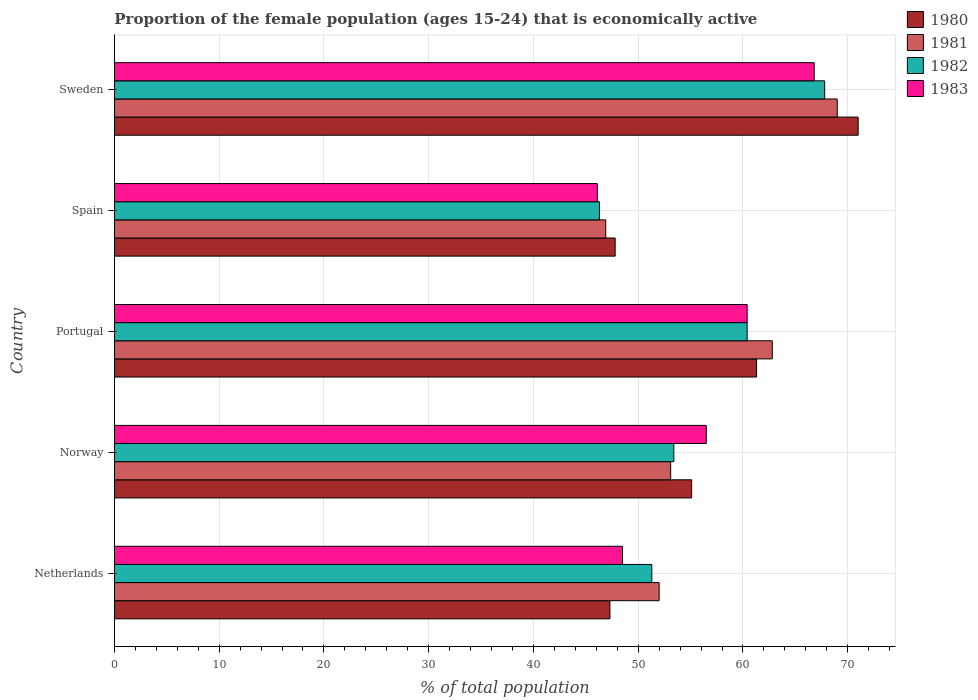How many groups of bars are there?
Offer a very short reply. 5. Are the number of bars on each tick of the Y-axis equal?
Provide a succinct answer. Yes. How many bars are there on the 1st tick from the bottom?
Give a very brief answer. 4. What is the label of the 1st group of bars from the top?
Your answer should be compact. Sweden. In how many cases, is the number of bars for a given country not equal to the number of legend labels?
Offer a terse response. 0. What is the proportion of the female population that is economically active in 1982 in Spain?
Offer a terse response. 46.3. Across all countries, what is the maximum proportion of the female population that is economically active in 1980?
Your response must be concise. 71. Across all countries, what is the minimum proportion of the female population that is economically active in 1983?
Ensure brevity in your answer.  46.1. What is the total proportion of the female population that is economically active in 1983 in the graph?
Offer a terse response. 278.3. What is the difference between the proportion of the female population that is economically active in 1982 in Spain and that in Sweden?
Ensure brevity in your answer.  -21.5. What is the difference between the proportion of the female population that is economically active in 1983 in Portugal and the proportion of the female population that is economically active in 1981 in Netherlands?
Keep it short and to the point. 8.4. What is the average proportion of the female population that is economically active in 1983 per country?
Your response must be concise. 55.66. What is the difference between the proportion of the female population that is economically active in 1981 and proportion of the female population that is economically active in 1982 in Sweden?
Offer a very short reply. 1.2. In how many countries, is the proportion of the female population that is economically active in 1980 greater than 44 %?
Your answer should be compact. 5. What is the ratio of the proportion of the female population that is economically active in 1983 in Norway to that in Spain?
Give a very brief answer. 1.23. Is the proportion of the female population that is economically active in 1981 in Netherlands less than that in Portugal?
Provide a succinct answer. Yes. What is the difference between the highest and the second highest proportion of the female population that is economically active in 1981?
Make the answer very short. 6.2. What is the difference between the highest and the lowest proportion of the female population that is economically active in 1980?
Make the answer very short. 23.7. Is the sum of the proportion of the female population that is economically active in 1981 in Netherlands and Sweden greater than the maximum proportion of the female population that is economically active in 1982 across all countries?
Provide a succinct answer. Yes. What does the 1st bar from the bottom in Spain represents?
Give a very brief answer. 1980. Does the graph contain any zero values?
Ensure brevity in your answer.  No. Where does the legend appear in the graph?
Your answer should be compact. Top right. What is the title of the graph?
Your response must be concise. Proportion of the female population (ages 15-24) that is economically active. Does "1997" appear as one of the legend labels in the graph?
Offer a very short reply. No. What is the label or title of the X-axis?
Your answer should be very brief. % of total population. What is the % of total population of 1980 in Netherlands?
Offer a terse response. 47.3. What is the % of total population in 1982 in Netherlands?
Your answer should be very brief. 51.3. What is the % of total population in 1983 in Netherlands?
Make the answer very short. 48.5. What is the % of total population of 1980 in Norway?
Your answer should be very brief. 55.1. What is the % of total population in 1981 in Norway?
Your answer should be compact. 53.1. What is the % of total population in 1982 in Norway?
Your response must be concise. 53.4. What is the % of total population of 1983 in Norway?
Offer a terse response. 56.5. What is the % of total population of 1980 in Portugal?
Make the answer very short. 61.3. What is the % of total population of 1981 in Portugal?
Your response must be concise. 62.8. What is the % of total population of 1982 in Portugal?
Offer a terse response. 60.4. What is the % of total population in 1983 in Portugal?
Your answer should be compact. 60.4. What is the % of total population in 1980 in Spain?
Provide a succinct answer. 47.8. What is the % of total population of 1981 in Spain?
Ensure brevity in your answer.  46.9. What is the % of total population of 1982 in Spain?
Keep it short and to the point. 46.3. What is the % of total population of 1983 in Spain?
Your response must be concise. 46.1. What is the % of total population of 1980 in Sweden?
Offer a very short reply. 71. What is the % of total population of 1981 in Sweden?
Offer a terse response. 69. What is the % of total population in 1982 in Sweden?
Offer a very short reply. 67.8. What is the % of total population in 1983 in Sweden?
Your response must be concise. 66.8. Across all countries, what is the maximum % of total population in 1980?
Offer a terse response. 71. Across all countries, what is the maximum % of total population in 1981?
Offer a terse response. 69. Across all countries, what is the maximum % of total population of 1982?
Provide a short and direct response. 67.8. Across all countries, what is the maximum % of total population in 1983?
Give a very brief answer. 66.8. Across all countries, what is the minimum % of total population of 1980?
Ensure brevity in your answer.  47.3. Across all countries, what is the minimum % of total population of 1981?
Provide a short and direct response. 46.9. Across all countries, what is the minimum % of total population in 1982?
Provide a short and direct response. 46.3. Across all countries, what is the minimum % of total population of 1983?
Keep it short and to the point. 46.1. What is the total % of total population in 1980 in the graph?
Make the answer very short. 282.5. What is the total % of total population of 1981 in the graph?
Your response must be concise. 283.8. What is the total % of total population of 1982 in the graph?
Your answer should be compact. 279.2. What is the total % of total population of 1983 in the graph?
Provide a succinct answer. 278.3. What is the difference between the % of total population in 1981 in Netherlands and that in Norway?
Your response must be concise. -1.1. What is the difference between the % of total population of 1983 in Netherlands and that in Norway?
Make the answer very short. -8. What is the difference between the % of total population in 1982 in Netherlands and that in Portugal?
Provide a short and direct response. -9.1. What is the difference between the % of total population in 1983 in Netherlands and that in Portugal?
Give a very brief answer. -11.9. What is the difference between the % of total population of 1980 in Netherlands and that in Spain?
Keep it short and to the point. -0.5. What is the difference between the % of total population in 1982 in Netherlands and that in Spain?
Keep it short and to the point. 5. What is the difference between the % of total population in 1983 in Netherlands and that in Spain?
Offer a terse response. 2.4. What is the difference between the % of total population of 1980 in Netherlands and that in Sweden?
Your response must be concise. -23.7. What is the difference between the % of total population in 1981 in Netherlands and that in Sweden?
Offer a very short reply. -17. What is the difference between the % of total population in 1982 in Netherlands and that in Sweden?
Keep it short and to the point. -16.5. What is the difference between the % of total population of 1983 in Netherlands and that in Sweden?
Make the answer very short. -18.3. What is the difference between the % of total population in 1980 in Norway and that in Portugal?
Your answer should be compact. -6.2. What is the difference between the % of total population in 1981 in Norway and that in Portugal?
Give a very brief answer. -9.7. What is the difference between the % of total population in 1982 in Norway and that in Portugal?
Provide a short and direct response. -7. What is the difference between the % of total population in 1980 in Norway and that in Spain?
Your answer should be very brief. 7.3. What is the difference between the % of total population in 1982 in Norway and that in Spain?
Your answer should be very brief. 7.1. What is the difference between the % of total population in 1980 in Norway and that in Sweden?
Provide a short and direct response. -15.9. What is the difference between the % of total population in 1981 in Norway and that in Sweden?
Give a very brief answer. -15.9. What is the difference between the % of total population of 1982 in Norway and that in Sweden?
Your response must be concise. -14.4. What is the difference between the % of total population of 1983 in Norway and that in Sweden?
Your response must be concise. -10.3. What is the difference between the % of total population of 1981 in Portugal and that in Spain?
Provide a short and direct response. 15.9. What is the difference between the % of total population in 1982 in Portugal and that in Spain?
Provide a succinct answer. 14.1. What is the difference between the % of total population in 1981 in Portugal and that in Sweden?
Your answer should be very brief. -6.2. What is the difference between the % of total population in 1982 in Portugal and that in Sweden?
Provide a short and direct response. -7.4. What is the difference between the % of total population of 1983 in Portugal and that in Sweden?
Keep it short and to the point. -6.4. What is the difference between the % of total population of 1980 in Spain and that in Sweden?
Give a very brief answer. -23.2. What is the difference between the % of total population of 1981 in Spain and that in Sweden?
Offer a terse response. -22.1. What is the difference between the % of total population in 1982 in Spain and that in Sweden?
Keep it short and to the point. -21.5. What is the difference between the % of total population of 1983 in Spain and that in Sweden?
Make the answer very short. -20.7. What is the difference between the % of total population in 1980 in Netherlands and the % of total population in 1982 in Norway?
Give a very brief answer. -6.1. What is the difference between the % of total population in 1981 in Netherlands and the % of total population in 1983 in Norway?
Ensure brevity in your answer.  -4.5. What is the difference between the % of total population of 1982 in Netherlands and the % of total population of 1983 in Norway?
Your answer should be very brief. -5.2. What is the difference between the % of total population of 1980 in Netherlands and the % of total population of 1981 in Portugal?
Provide a short and direct response. -15.5. What is the difference between the % of total population of 1980 in Netherlands and the % of total population of 1983 in Portugal?
Ensure brevity in your answer.  -13.1. What is the difference between the % of total population of 1980 in Netherlands and the % of total population of 1981 in Spain?
Provide a succinct answer. 0.4. What is the difference between the % of total population in 1980 in Netherlands and the % of total population in 1982 in Spain?
Your answer should be compact. 1. What is the difference between the % of total population in 1980 in Netherlands and the % of total population in 1983 in Spain?
Provide a short and direct response. 1.2. What is the difference between the % of total population of 1981 in Netherlands and the % of total population of 1982 in Spain?
Your response must be concise. 5.7. What is the difference between the % of total population of 1981 in Netherlands and the % of total population of 1983 in Spain?
Your response must be concise. 5.9. What is the difference between the % of total population in 1980 in Netherlands and the % of total population in 1981 in Sweden?
Your answer should be very brief. -21.7. What is the difference between the % of total population in 1980 in Netherlands and the % of total population in 1982 in Sweden?
Give a very brief answer. -20.5. What is the difference between the % of total population of 1980 in Netherlands and the % of total population of 1983 in Sweden?
Your answer should be very brief. -19.5. What is the difference between the % of total population of 1981 in Netherlands and the % of total population of 1982 in Sweden?
Make the answer very short. -15.8. What is the difference between the % of total population in 1981 in Netherlands and the % of total population in 1983 in Sweden?
Your response must be concise. -14.8. What is the difference between the % of total population of 1982 in Netherlands and the % of total population of 1983 in Sweden?
Give a very brief answer. -15.5. What is the difference between the % of total population in 1980 in Norway and the % of total population in 1983 in Portugal?
Provide a short and direct response. -5.3. What is the difference between the % of total population in 1981 in Norway and the % of total population in 1982 in Portugal?
Keep it short and to the point. -7.3. What is the difference between the % of total population of 1982 in Norway and the % of total population of 1983 in Portugal?
Ensure brevity in your answer.  -7. What is the difference between the % of total population of 1980 in Norway and the % of total population of 1982 in Spain?
Provide a succinct answer. 8.8. What is the difference between the % of total population of 1980 in Norway and the % of total population of 1983 in Spain?
Provide a short and direct response. 9. What is the difference between the % of total population of 1981 in Norway and the % of total population of 1983 in Spain?
Provide a short and direct response. 7. What is the difference between the % of total population of 1982 in Norway and the % of total population of 1983 in Spain?
Your response must be concise. 7.3. What is the difference between the % of total population of 1980 in Norway and the % of total population of 1983 in Sweden?
Keep it short and to the point. -11.7. What is the difference between the % of total population in 1981 in Norway and the % of total population in 1982 in Sweden?
Your response must be concise. -14.7. What is the difference between the % of total population in 1981 in Norway and the % of total population in 1983 in Sweden?
Make the answer very short. -13.7. What is the difference between the % of total population in 1980 in Portugal and the % of total population in 1981 in Spain?
Provide a succinct answer. 14.4. What is the difference between the % of total population of 1980 in Portugal and the % of total population of 1982 in Spain?
Your response must be concise. 15. What is the difference between the % of total population of 1980 in Portugal and the % of total population of 1983 in Spain?
Keep it short and to the point. 15.2. What is the difference between the % of total population in 1981 in Portugal and the % of total population in 1982 in Spain?
Ensure brevity in your answer.  16.5. What is the difference between the % of total population in 1981 in Portugal and the % of total population in 1983 in Spain?
Make the answer very short. 16.7. What is the difference between the % of total population in 1981 in Portugal and the % of total population in 1982 in Sweden?
Your answer should be compact. -5. What is the difference between the % of total population in 1980 in Spain and the % of total population in 1981 in Sweden?
Your answer should be compact. -21.2. What is the difference between the % of total population of 1980 in Spain and the % of total population of 1982 in Sweden?
Give a very brief answer. -20. What is the difference between the % of total population in 1981 in Spain and the % of total population in 1982 in Sweden?
Ensure brevity in your answer.  -20.9. What is the difference between the % of total population of 1981 in Spain and the % of total population of 1983 in Sweden?
Offer a very short reply. -19.9. What is the difference between the % of total population of 1982 in Spain and the % of total population of 1983 in Sweden?
Keep it short and to the point. -20.5. What is the average % of total population in 1980 per country?
Your answer should be very brief. 56.5. What is the average % of total population of 1981 per country?
Your answer should be compact. 56.76. What is the average % of total population of 1982 per country?
Your response must be concise. 55.84. What is the average % of total population of 1983 per country?
Your answer should be very brief. 55.66. What is the difference between the % of total population in 1980 and % of total population in 1981 in Netherlands?
Provide a succinct answer. -4.7. What is the difference between the % of total population in 1981 and % of total population in 1982 in Netherlands?
Offer a terse response. 0.7. What is the difference between the % of total population in 1981 and % of total population in 1983 in Netherlands?
Offer a terse response. 3.5. What is the difference between the % of total population in 1980 and % of total population in 1981 in Norway?
Keep it short and to the point. 2. What is the difference between the % of total population of 1980 and % of total population of 1983 in Norway?
Keep it short and to the point. -1.4. What is the difference between the % of total population in 1981 and % of total population in 1983 in Norway?
Offer a very short reply. -3.4. What is the difference between the % of total population of 1982 and % of total population of 1983 in Norway?
Your answer should be compact. -3.1. What is the difference between the % of total population of 1980 and % of total population of 1981 in Spain?
Offer a very short reply. 0.9. What is the difference between the % of total population of 1980 and % of total population of 1982 in Spain?
Make the answer very short. 1.5. What is the difference between the % of total population of 1980 and % of total population of 1983 in Spain?
Offer a terse response. 1.7. What is the difference between the % of total population in 1981 and % of total population in 1982 in Spain?
Your response must be concise. 0.6. What is the difference between the % of total population of 1981 and % of total population of 1983 in Spain?
Give a very brief answer. 0.8. What is the difference between the % of total population in 1980 and % of total population in 1981 in Sweden?
Your response must be concise. 2. What is the difference between the % of total population in 1980 and % of total population in 1983 in Sweden?
Offer a very short reply. 4.2. What is the difference between the % of total population in 1981 and % of total population in 1982 in Sweden?
Provide a short and direct response. 1.2. What is the difference between the % of total population of 1981 and % of total population of 1983 in Sweden?
Your answer should be compact. 2.2. What is the difference between the % of total population in 1982 and % of total population in 1983 in Sweden?
Your answer should be compact. 1. What is the ratio of the % of total population in 1980 in Netherlands to that in Norway?
Your answer should be compact. 0.86. What is the ratio of the % of total population in 1981 in Netherlands to that in Norway?
Give a very brief answer. 0.98. What is the ratio of the % of total population of 1982 in Netherlands to that in Norway?
Provide a short and direct response. 0.96. What is the ratio of the % of total population of 1983 in Netherlands to that in Norway?
Provide a short and direct response. 0.86. What is the ratio of the % of total population of 1980 in Netherlands to that in Portugal?
Your answer should be compact. 0.77. What is the ratio of the % of total population of 1981 in Netherlands to that in Portugal?
Offer a very short reply. 0.83. What is the ratio of the % of total population of 1982 in Netherlands to that in Portugal?
Keep it short and to the point. 0.85. What is the ratio of the % of total population in 1983 in Netherlands to that in Portugal?
Provide a succinct answer. 0.8. What is the ratio of the % of total population of 1981 in Netherlands to that in Spain?
Ensure brevity in your answer.  1.11. What is the ratio of the % of total population in 1982 in Netherlands to that in Spain?
Offer a terse response. 1.11. What is the ratio of the % of total population in 1983 in Netherlands to that in Spain?
Ensure brevity in your answer.  1.05. What is the ratio of the % of total population of 1980 in Netherlands to that in Sweden?
Ensure brevity in your answer.  0.67. What is the ratio of the % of total population of 1981 in Netherlands to that in Sweden?
Offer a terse response. 0.75. What is the ratio of the % of total population of 1982 in Netherlands to that in Sweden?
Your answer should be very brief. 0.76. What is the ratio of the % of total population in 1983 in Netherlands to that in Sweden?
Provide a short and direct response. 0.73. What is the ratio of the % of total population of 1980 in Norway to that in Portugal?
Provide a succinct answer. 0.9. What is the ratio of the % of total population of 1981 in Norway to that in Portugal?
Your answer should be compact. 0.85. What is the ratio of the % of total population in 1982 in Norway to that in Portugal?
Your answer should be very brief. 0.88. What is the ratio of the % of total population in 1983 in Norway to that in Portugal?
Provide a succinct answer. 0.94. What is the ratio of the % of total population in 1980 in Norway to that in Spain?
Give a very brief answer. 1.15. What is the ratio of the % of total population of 1981 in Norway to that in Spain?
Keep it short and to the point. 1.13. What is the ratio of the % of total population in 1982 in Norway to that in Spain?
Make the answer very short. 1.15. What is the ratio of the % of total population in 1983 in Norway to that in Spain?
Make the answer very short. 1.23. What is the ratio of the % of total population in 1980 in Norway to that in Sweden?
Keep it short and to the point. 0.78. What is the ratio of the % of total population of 1981 in Norway to that in Sweden?
Provide a short and direct response. 0.77. What is the ratio of the % of total population in 1982 in Norway to that in Sweden?
Your answer should be very brief. 0.79. What is the ratio of the % of total population in 1983 in Norway to that in Sweden?
Offer a very short reply. 0.85. What is the ratio of the % of total population in 1980 in Portugal to that in Spain?
Provide a succinct answer. 1.28. What is the ratio of the % of total population in 1981 in Portugal to that in Spain?
Ensure brevity in your answer.  1.34. What is the ratio of the % of total population of 1982 in Portugal to that in Spain?
Make the answer very short. 1.3. What is the ratio of the % of total population of 1983 in Portugal to that in Spain?
Give a very brief answer. 1.31. What is the ratio of the % of total population of 1980 in Portugal to that in Sweden?
Make the answer very short. 0.86. What is the ratio of the % of total population in 1981 in Portugal to that in Sweden?
Provide a short and direct response. 0.91. What is the ratio of the % of total population in 1982 in Portugal to that in Sweden?
Offer a terse response. 0.89. What is the ratio of the % of total population of 1983 in Portugal to that in Sweden?
Make the answer very short. 0.9. What is the ratio of the % of total population in 1980 in Spain to that in Sweden?
Keep it short and to the point. 0.67. What is the ratio of the % of total population of 1981 in Spain to that in Sweden?
Offer a very short reply. 0.68. What is the ratio of the % of total population of 1982 in Spain to that in Sweden?
Your answer should be very brief. 0.68. What is the ratio of the % of total population of 1983 in Spain to that in Sweden?
Provide a short and direct response. 0.69. What is the difference between the highest and the second highest % of total population of 1980?
Your response must be concise. 9.7. What is the difference between the highest and the second highest % of total population of 1982?
Your answer should be very brief. 7.4. What is the difference between the highest and the second highest % of total population in 1983?
Ensure brevity in your answer.  6.4. What is the difference between the highest and the lowest % of total population of 1980?
Provide a short and direct response. 23.7. What is the difference between the highest and the lowest % of total population in 1981?
Your answer should be very brief. 22.1. What is the difference between the highest and the lowest % of total population of 1982?
Make the answer very short. 21.5. What is the difference between the highest and the lowest % of total population in 1983?
Offer a terse response. 20.7. 